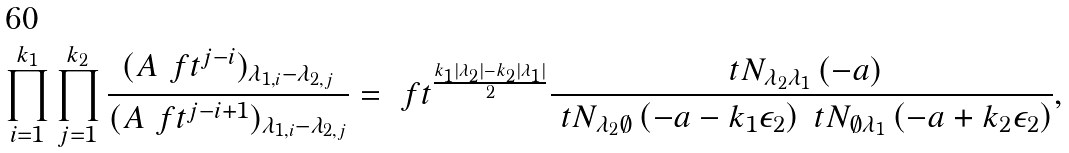<formula> <loc_0><loc_0><loc_500><loc_500>\prod _ { i = 1 } ^ { k _ { 1 } } \prod _ { j = 1 } ^ { k _ { 2 } } \frac { ( A \ f t ^ { j - i } ) _ { \lambda _ { 1 , i } - \lambda _ { 2 , j } } } { ( A \ f t ^ { j - i + 1 } ) _ { \lambda _ { 1 , i } - \lambda _ { 2 , j } } } = \ f t ^ { \frac { k _ { 1 } | \lambda _ { 2 } | - k _ { 2 } | \lambda _ { 1 } | } { 2 } } \frac { \ t N _ { \lambda _ { 2 } \lambda _ { 1 } } \left ( - a \right ) } { \ t N _ { \lambda _ { 2 } \emptyset } \left ( - a - k _ { 1 } \epsilon _ { 2 } \right ) \ t N _ { \emptyset \lambda _ { 1 } } \left ( - a + k _ { 2 } \epsilon _ { 2 } \right ) } ,</formula> 